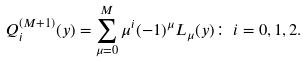<formula> <loc_0><loc_0><loc_500><loc_500>Q _ { i } ^ { ( M + 1 ) } ( y ) = \sum _ { \mu = 0 } ^ { M } \mu ^ { i } ( - 1 ) ^ { \mu } L _ { \mu } ( y ) \colon \, i = 0 , 1 , 2 .</formula> 